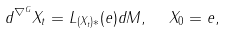<formula> <loc_0><loc_0><loc_500><loc_500>d ^ { \nabla ^ { G } } X _ { t } = L _ { ( X _ { t } ) * } ( e ) d M , \ \ X _ { 0 } = e ,</formula> 